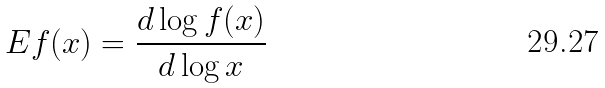Convert formula to latex. <formula><loc_0><loc_0><loc_500><loc_500>E f ( x ) = \frac { d \log f ( x ) } { d \log x }</formula> 